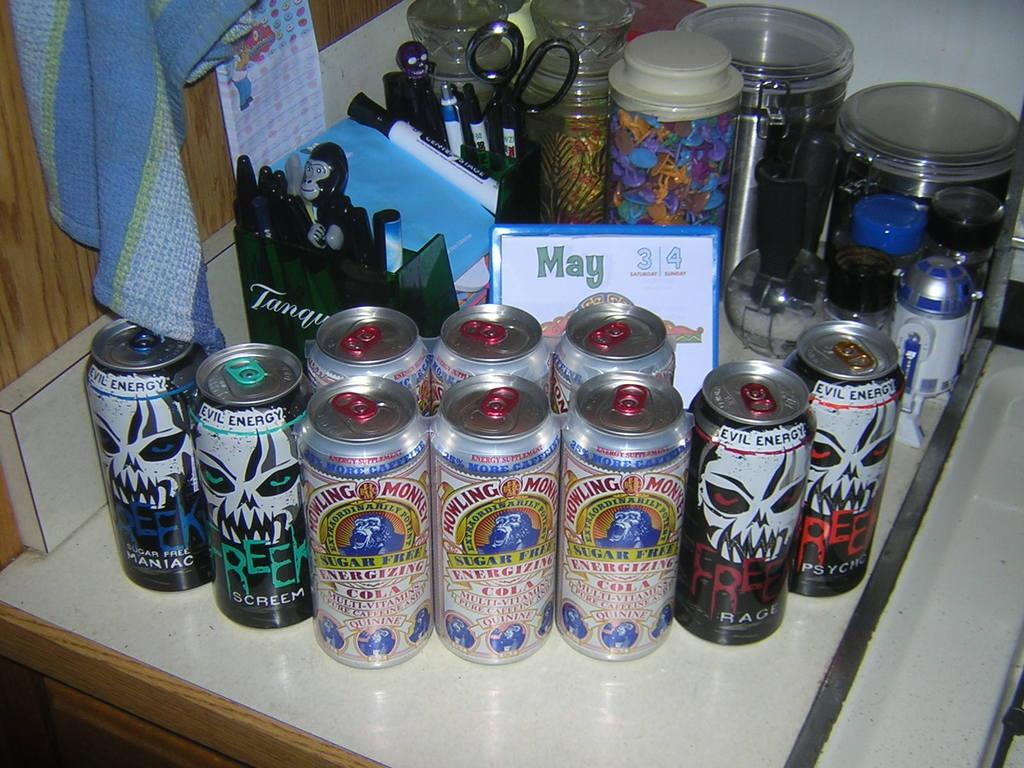<image>
Present a compact description of the photo's key features. cans on a table including Freek Evil Energy 